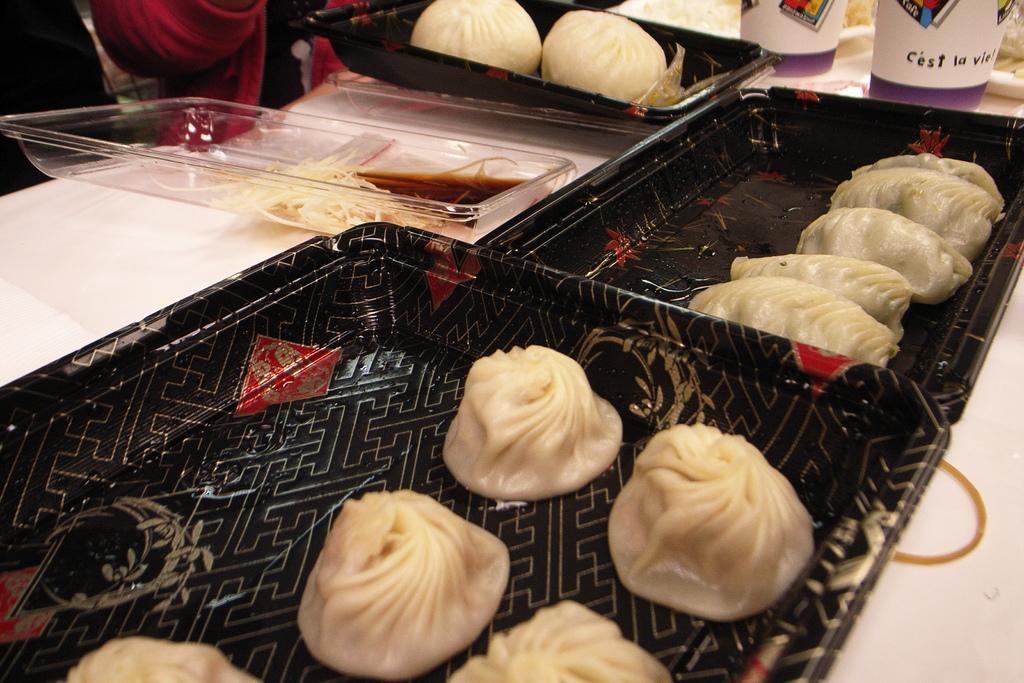Please provide a concise description of this image. In this image we can see some food items are kept on black color trays. Also, we can see cups are placed on the white color surface. 